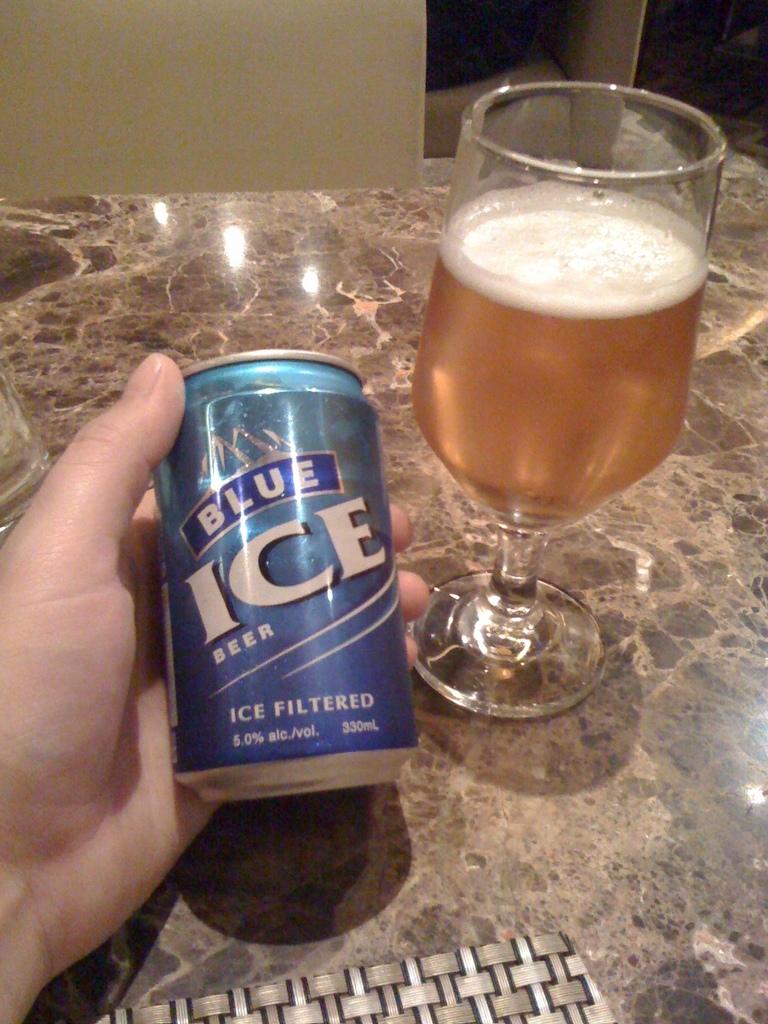Is this a can of blue ice?
Offer a terse response. Yes. What is the brand of beer?
Offer a terse response. Blue ice. 